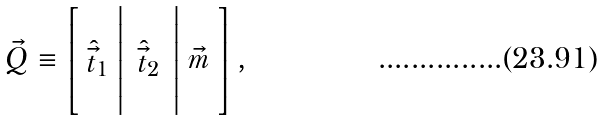Convert formula to latex. <formula><loc_0><loc_0><loc_500><loc_500>\vec { Q } \equiv \left [ \begin{array} { c } \\ \hat { \vec { t } } _ { 1 } \\ \\ \end{array} \right | \begin{array} { c } \\ \hat { \vec { t } } _ { 2 } \\ \\ \end{array} \left | \begin{array} { c } \\ \vec { m } \\ \\ \end{array} \right ] ,</formula> 